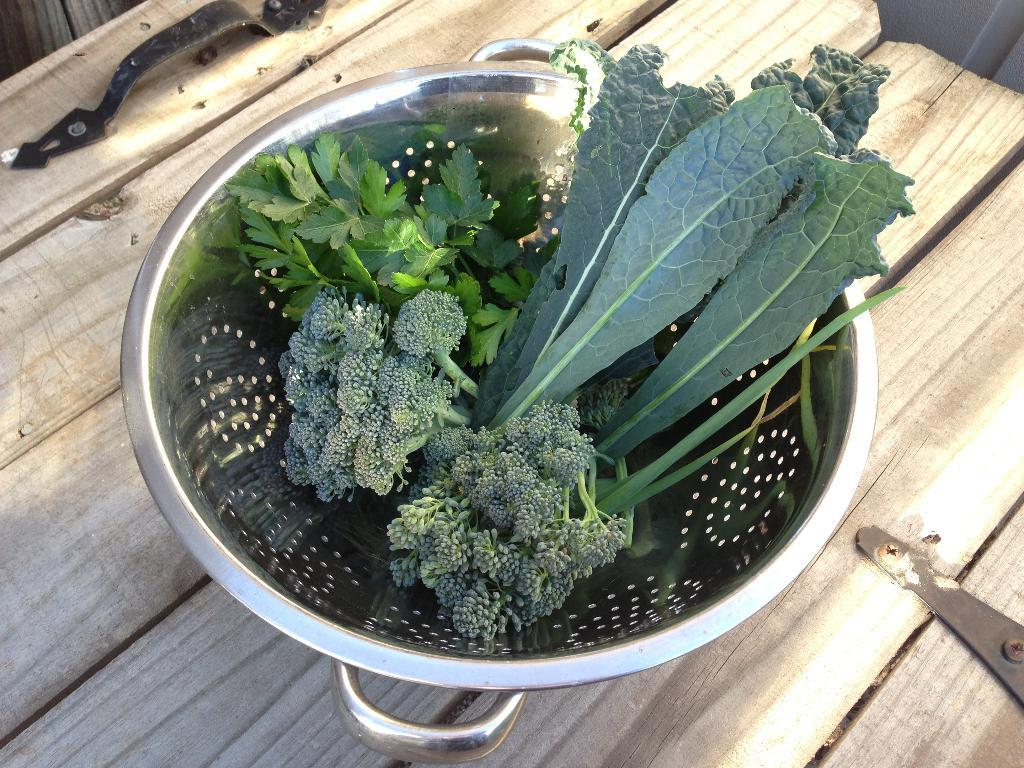What type of food is in the bowl in the image? There are leafy vegetables in a bowl in the image. What material is the table made of? The table in the image is made of wood. Can you describe any other furniture in the image? There might be a chair in the background of the image, but it is not clearly visible. How many cherries are on the muscle in the image? There are no cherries or muscles present in the image. 